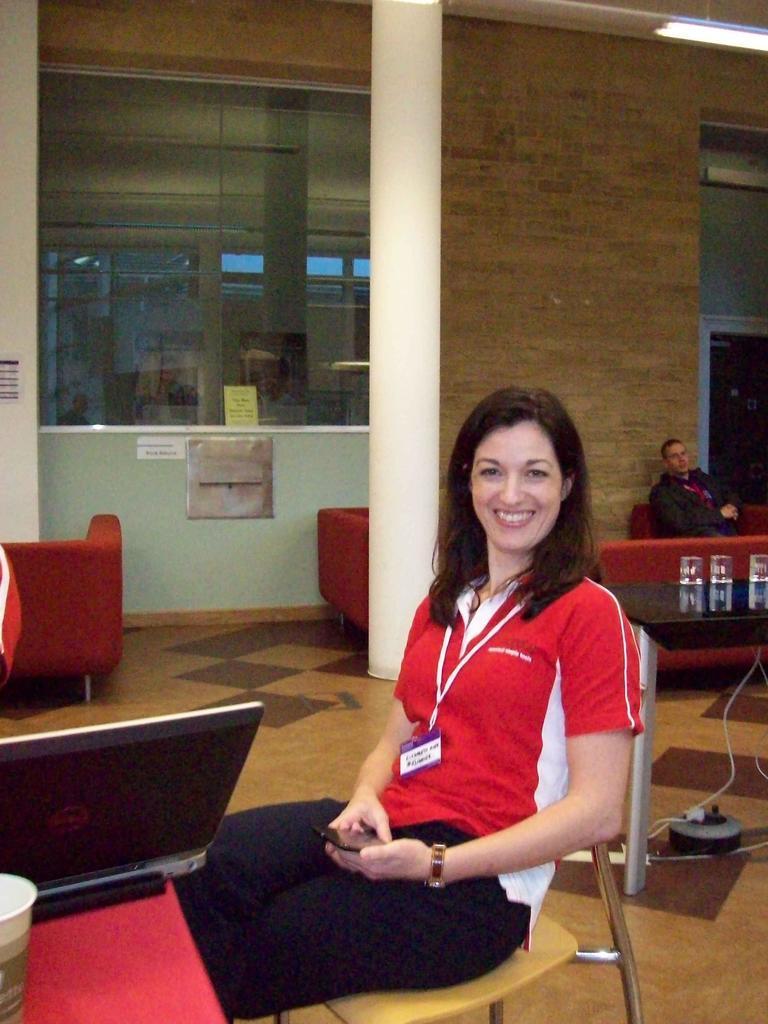In one or two sentences, can you explain what this image depicts? A woman is sitting in the chair wearing red color T-shirt,smiling behind her there is a man and wall. 